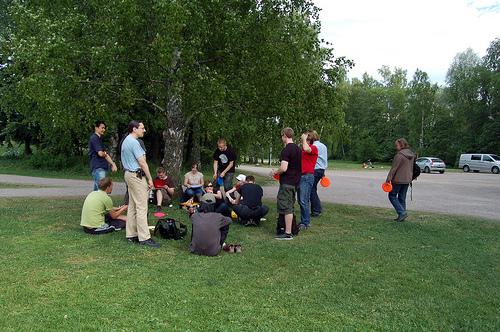Where are the people gathered?
Keep it brief. Park. What event are the people attending?
Keep it brief. Frisbee. Is this an outdoor meal?
Write a very short answer. No. Are they playing a game?
Short answer required. Yes. How many people are standing?
Write a very short answer. 7. 